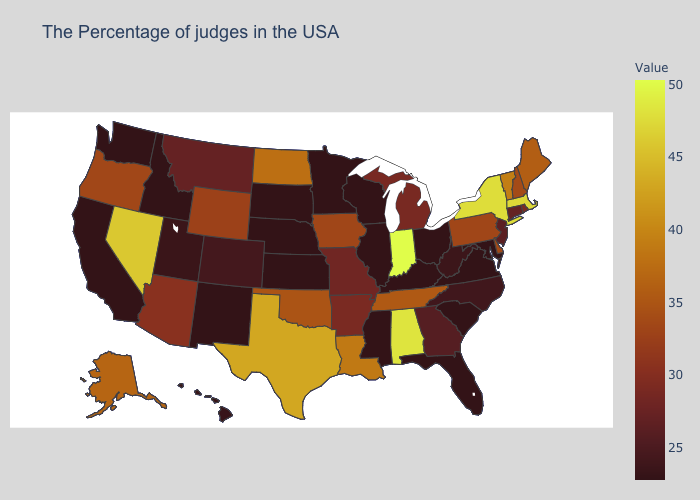Among the states that border Arkansas , which have the highest value?
Concise answer only. Texas. Is the legend a continuous bar?
Give a very brief answer. Yes. Among the states that border Oklahoma , which have the highest value?
Quick response, please. Texas. Does New Jersey have the lowest value in the USA?
Answer briefly. No. Does the map have missing data?
Be succinct. No. Does Wyoming have the highest value in the West?
Keep it brief. No. Which states have the lowest value in the USA?
Write a very short answer. Maryland, Virginia, South Carolina, Ohio, Florida, Kentucky, Wisconsin, Illinois, Mississippi, Minnesota, Kansas, Nebraska, South Dakota, New Mexico, Idaho, California, Washington. 